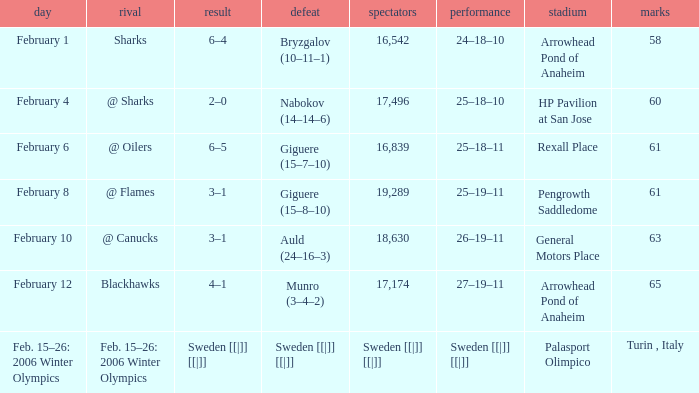What is the record at Arrowhead Pond of Anaheim, when the loss was Bryzgalov (10–11–1)? 24–18–10. 